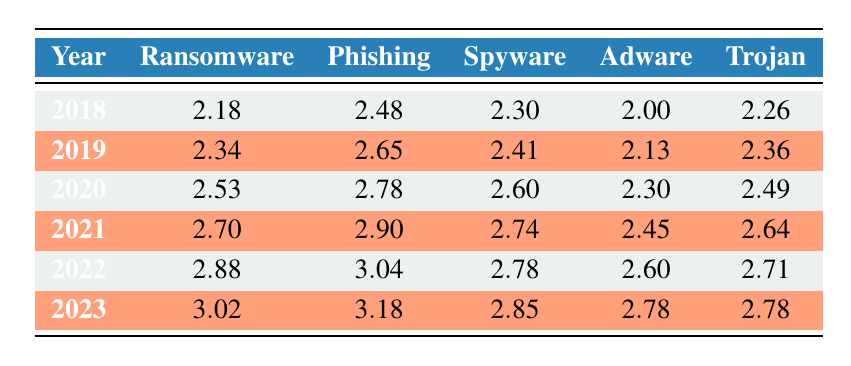What was the value of ransomware in 2022? The table shows the ransomware value for the year 2022 as 2.88.
Answer: 2.88 Which malware type had the highest growth from 2018 to 2023? By comparing the values in the ransomware column from 2018 (2.18) to 2023 (3.02), we see that ransomware grew the most. The difference is 3.02 - 2.18 = 0.84.
Answer: Ransomware What is the average value of spyware from 2018 to 2023? The spyware values for those years are 2.30, 2.41, 2.60, 2.74, 2.78, and 2.85. Adding these together gives us 15.68. Dividing this by 6 (the number of years) results in an average of 15.68 / 6 = 2.61.
Answer: 2.61 Did phishing malware decrease from 2021 to 2023? The phishing values for those years are 2.90 (2021) and 3.18 (2023). Since 3.18 is greater than 2.90, phishing did not decrease.
Answer: No What was the total increase in adware from 2018 to 2023? The adware values in 2018 and 2023 are 2.00 and 2.78, respectively. The increase is calculated as 2.78 - 2.00 = 0.78.
Answer: 0.78 Which year had the highest value of trojan malware? By examining the trojan column, we see that the highest value is 2.78 in 2023.
Answer: 2023 What is the ratio of ransomware to adware in 2020? In 2020, ransomware is at 2.53 and adware at 2.30. The ratio is calculated as 2.53 / 2.30 = 1.10.
Answer: 1.10 Is it true that spyware exhibited the highest persistence compared to other malware types in 2023? In 2023, spyware has a value of 2.85, which is lower than the phishing (3.18) and ransomware (3.02) values. Therefore, spyware does not show the highest persistence.
Answer: No What was the percentage growth of phishing malware from 2018 to 2023? Phishing values are 2.48 in 2018 and 3.18 in 2023. The growth is calculated as ((3.18 - 2.48) / 2.48) * 100 = 28.06%.
Answer: 28.06% 